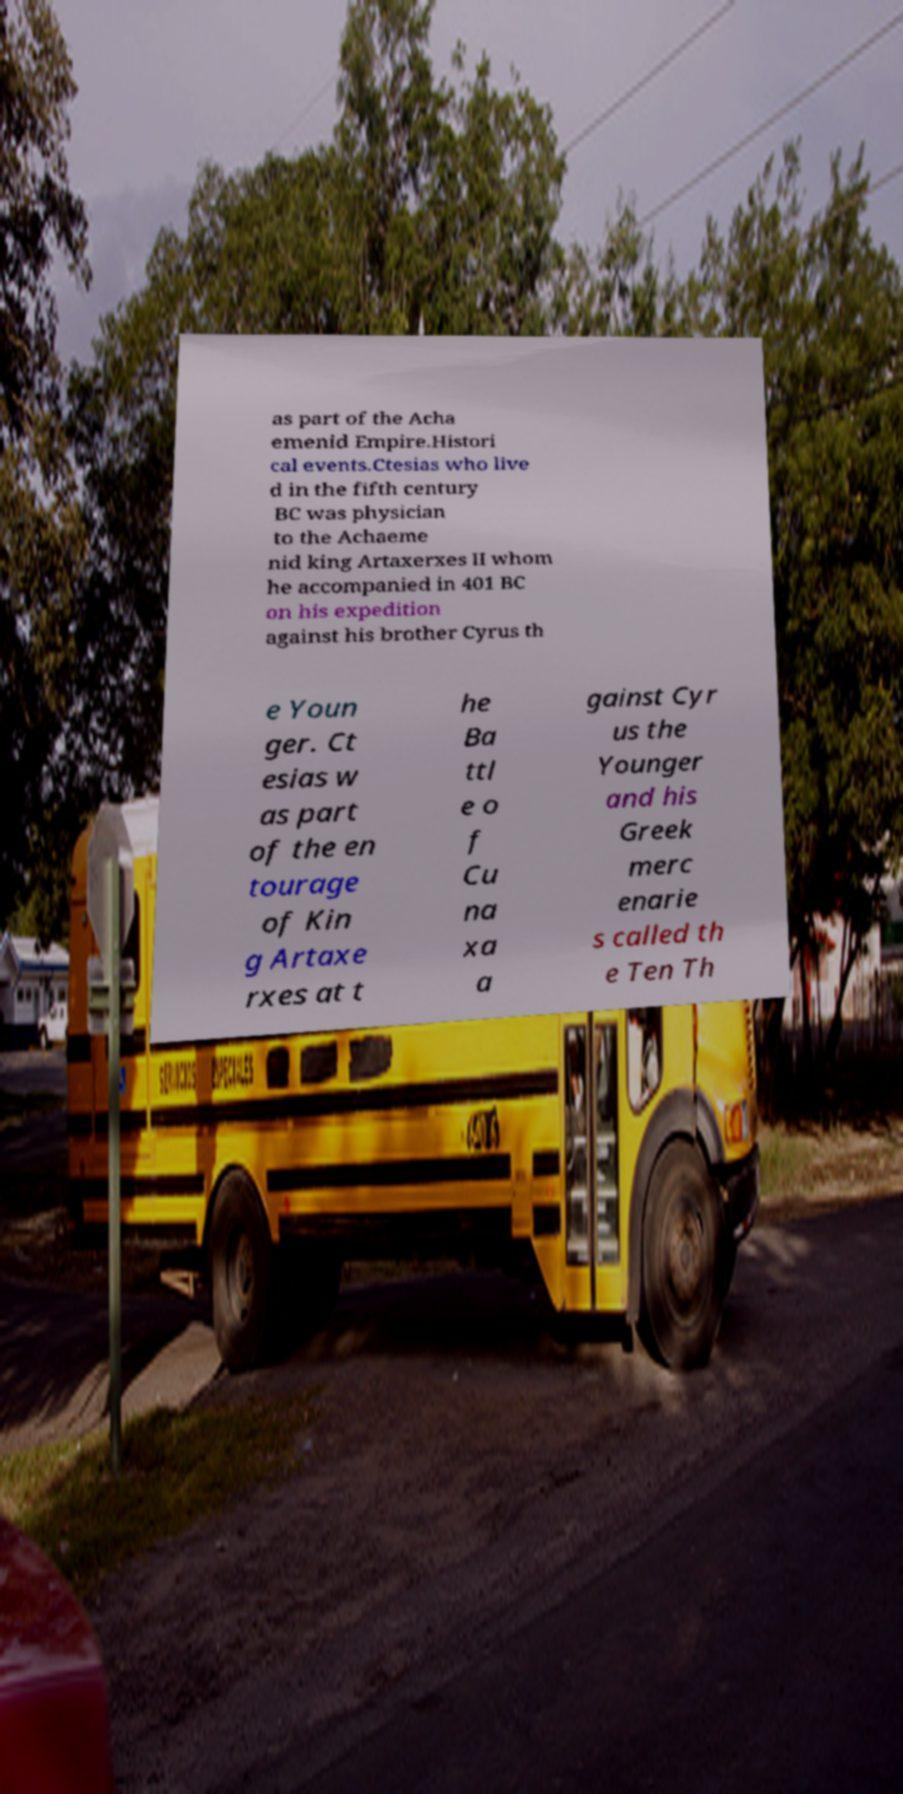There's text embedded in this image that I need extracted. Can you transcribe it verbatim? as part of the Acha emenid Empire.Histori cal events.Ctesias who live d in the fifth century BC was physician to the Achaeme nid king Artaxerxes II whom he accompanied in 401 BC on his expedition against his brother Cyrus th e Youn ger. Ct esias w as part of the en tourage of Kin g Artaxe rxes at t he Ba ttl e o f Cu na xa a gainst Cyr us the Younger and his Greek merc enarie s called th e Ten Th 